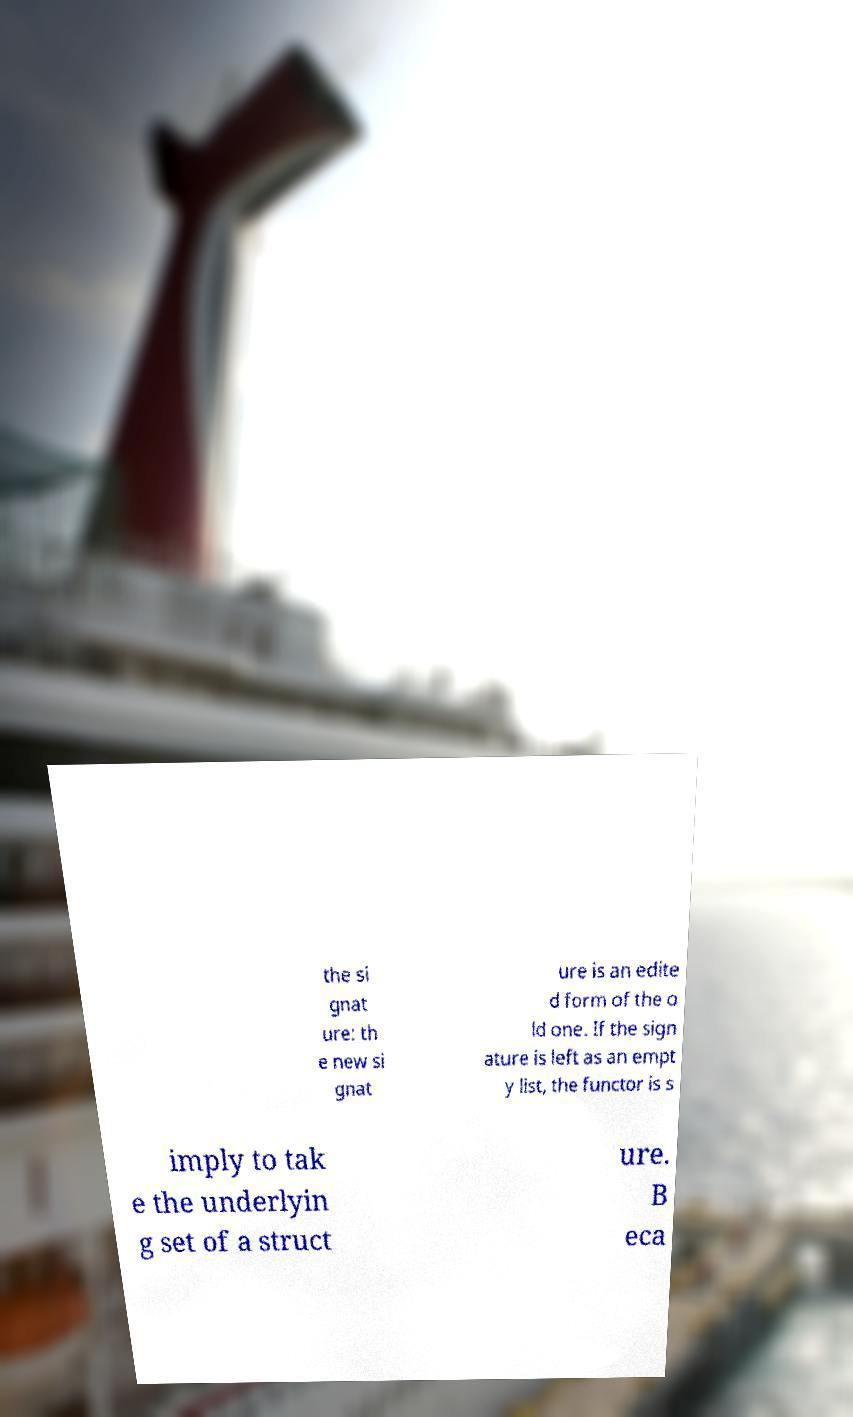Can you accurately transcribe the text from the provided image for me? the si gnat ure: th e new si gnat ure is an edite d form of the o ld one. If the sign ature is left as an empt y list, the functor is s imply to tak e the underlyin g set of a struct ure. B eca 